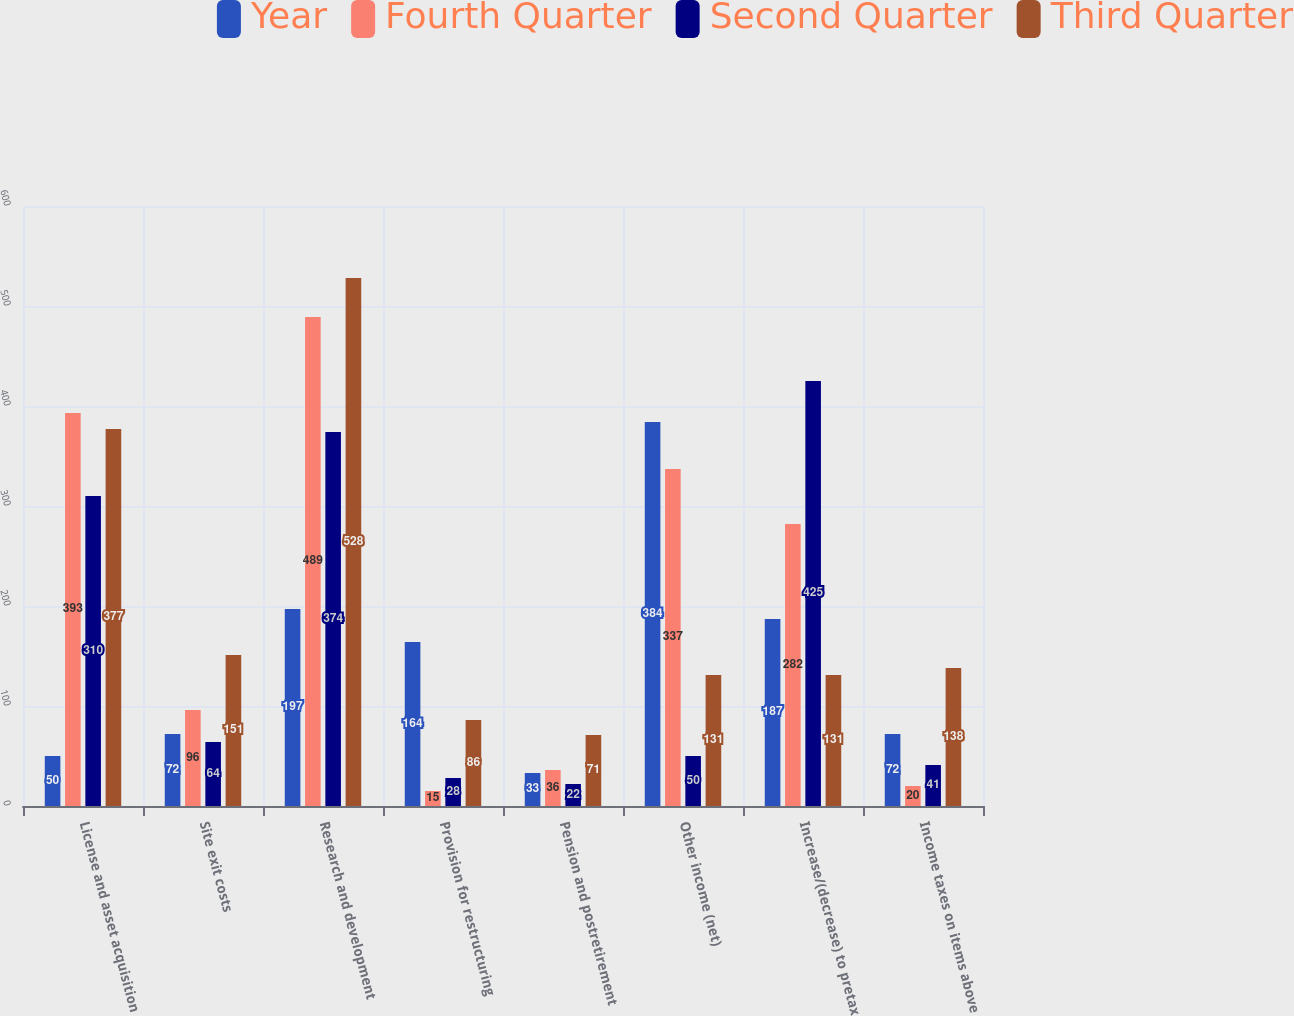<chart> <loc_0><loc_0><loc_500><loc_500><stacked_bar_chart><ecel><fcel>License and asset acquisition<fcel>Site exit costs<fcel>Research and development<fcel>Provision for restructuring<fcel>Pension and postretirement<fcel>Other income (net)<fcel>Increase/(decrease) to pretax<fcel>Income taxes on items above<nl><fcel>Year<fcel>50<fcel>72<fcel>197<fcel>164<fcel>33<fcel>384<fcel>187<fcel>72<nl><fcel>Fourth Quarter<fcel>393<fcel>96<fcel>489<fcel>15<fcel>36<fcel>337<fcel>282<fcel>20<nl><fcel>Second Quarter<fcel>310<fcel>64<fcel>374<fcel>28<fcel>22<fcel>50<fcel>425<fcel>41<nl><fcel>Third Quarter<fcel>377<fcel>151<fcel>528<fcel>86<fcel>71<fcel>131<fcel>131<fcel>138<nl></chart> 